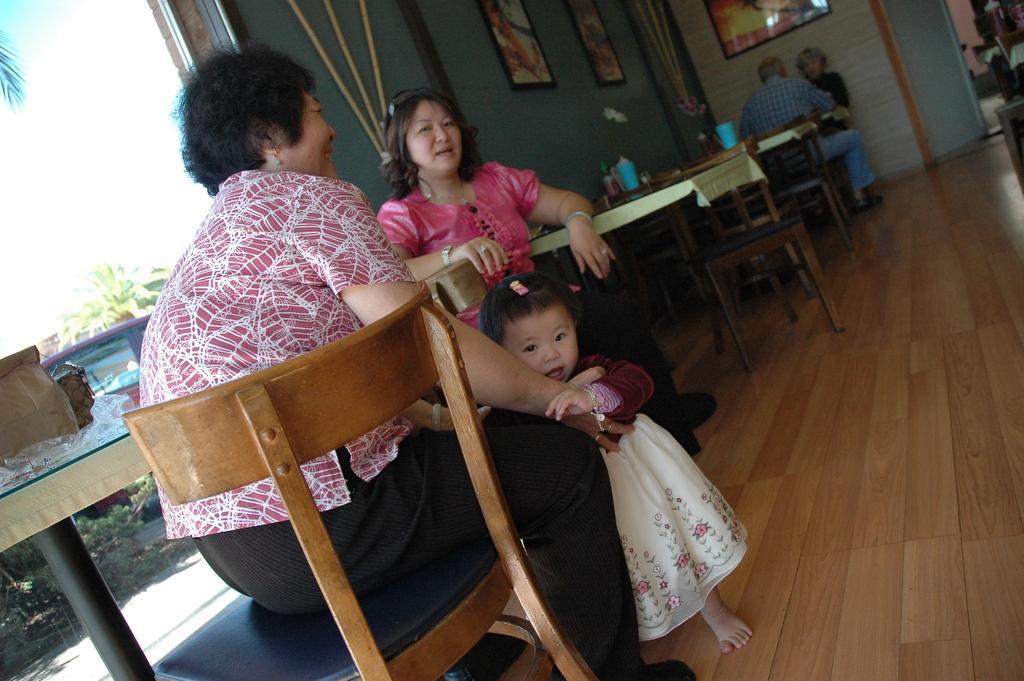Could you give a brief overview of what you see in this image? In the image we can see there are four people wearing clothes, they are sitting on the chair and there is a child standing. This is a wooden floor, table, window, frame, wall and a door. On the table there are many other things and out of the windows there are many other things and a vehicle. 